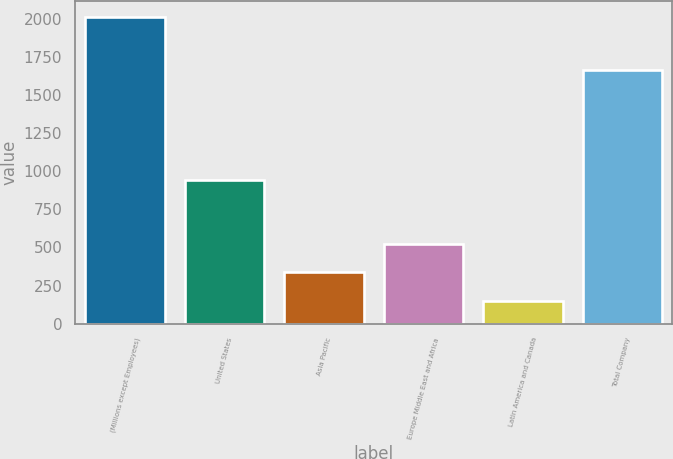Convert chart. <chart><loc_0><loc_0><loc_500><loc_500><bar_chart><fcel>(Millions except Employees)<fcel>United States<fcel>Asia Pacific<fcel>Europe Middle East and Africa<fcel>Latin America and Canada<fcel>Total Company<nl><fcel>2013<fcel>941<fcel>336.3<fcel>522.6<fcel>150<fcel>1665<nl></chart> 